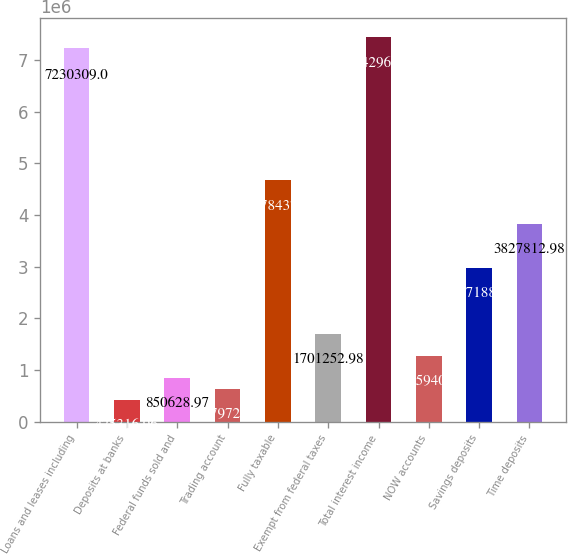Convert chart. <chart><loc_0><loc_0><loc_500><loc_500><bar_chart><fcel>Loans and leases including<fcel>Deposits at banks<fcel>Federal funds sold and<fcel>Trading account<fcel>Fully taxable<fcel>Exempt from federal taxes<fcel>Total interest income<fcel>NOW accounts<fcel>Savings deposits<fcel>Time deposits<nl><fcel>7.23031e+06<fcel>425317<fcel>850629<fcel>637973<fcel>4.67844e+06<fcel>1.70125e+06<fcel>7.44296e+06<fcel>1.27594e+06<fcel>2.97719e+06<fcel>3.82781e+06<nl></chart> 